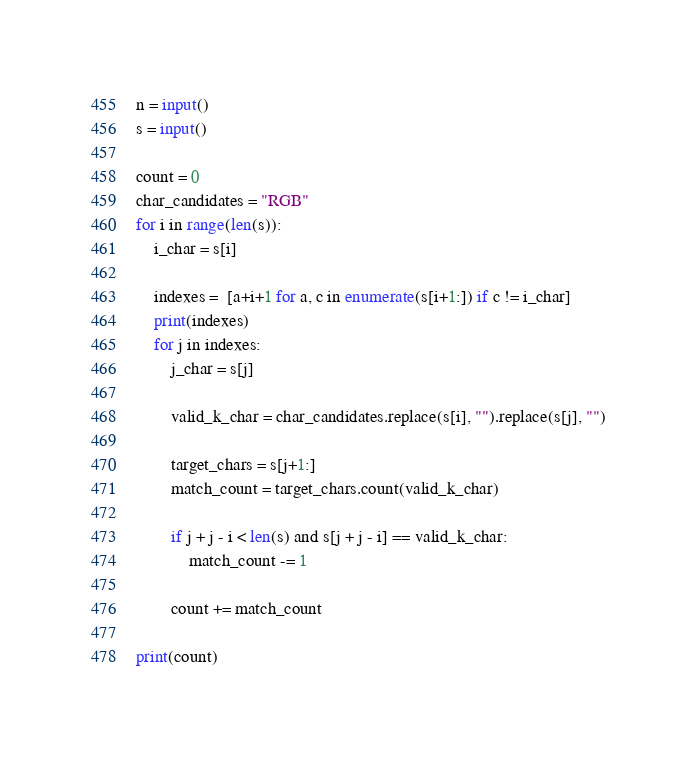Convert code to text. <code><loc_0><loc_0><loc_500><loc_500><_Python_>n = input()
s = input()

count = 0
char_candidates = "RGB"
for i in range(len(s)):
    i_char = s[i]

    indexes =  [a+i+1 for a, c in enumerate(s[i+1:]) if c != i_char]
    print(indexes)
    for j in indexes:
        j_char = s[j]
        
        valid_k_char = char_candidates.replace(s[i], "").replace(s[j], "")

        target_chars = s[j+1:]
        match_count = target_chars.count(valid_k_char)

        if j + j - i < len(s) and s[j + j - i] == valid_k_char:
            match_count -= 1

        count += match_count

print(count)</code> 